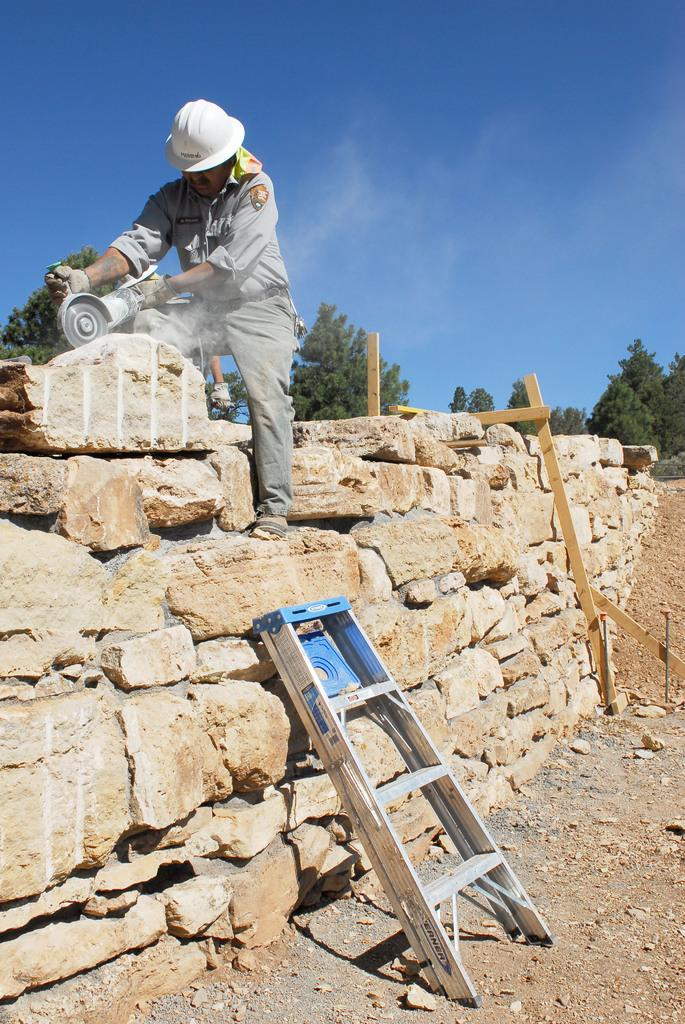What is the man in the image doing? The man is standing in the image. What is the man wearing on his head? The man is wearing a helmet. What is the man holding in his hand? The man is holding a tool. What type of objects can be seen in the image? There are rocks, a ladder, and wooden objects in the image. What can be seen in the background of the image? There are trees and the sky visible in the background of the image. What type of zipper can be seen on the man's helmet in the image? There is no zipper present on the man's helmet in the image. What type of legal advice is the man seeking in the image? There is no indication in the image that the man is seeking legal advice or interacting with a lawyer. 